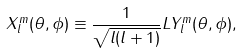<formula> <loc_0><loc_0><loc_500><loc_500>X _ { l } ^ { m } ( \theta , \phi ) \equiv \frac { 1 } { \sqrt { l ( l + 1 ) } } L Y _ { l } ^ { m } ( \theta , \phi ) ,</formula> 